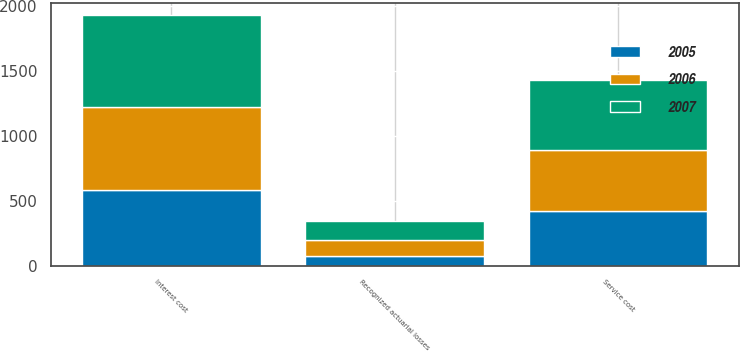Convert chart to OTSL. <chart><loc_0><loc_0><loc_500><loc_500><stacked_bar_chart><ecel><fcel>Service cost<fcel>Interest cost<fcel>Recognized actuarial losses<nl><fcel>2007<fcel>540<fcel>707<fcel>150<nl><fcel>2006<fcel>473<fcel>642<fcel>121<nl><fcel>2005<fcel>417<fcel>579<fcel>72<nl></chart> 